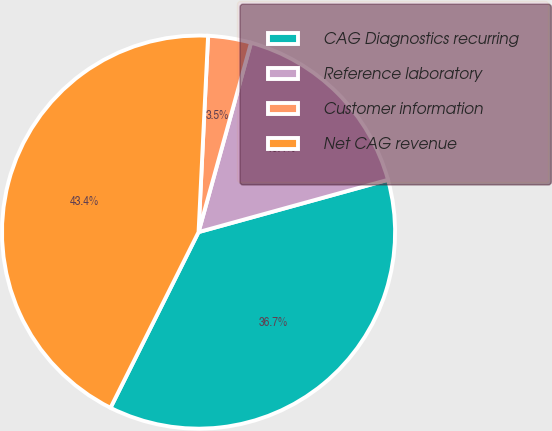Convert chart. <chart><loc_0><loc_0><loc_500><loc_500><pie_chart><fcel>CAG Diagnostics recurring<fcel>Reference laboratory<fcel>Customer information<fcel>Net CAG revenue<nl><fcel>36.68%<fcel>16.41%<fcel>3.53%<fcel>43.38%<nl></chart> 